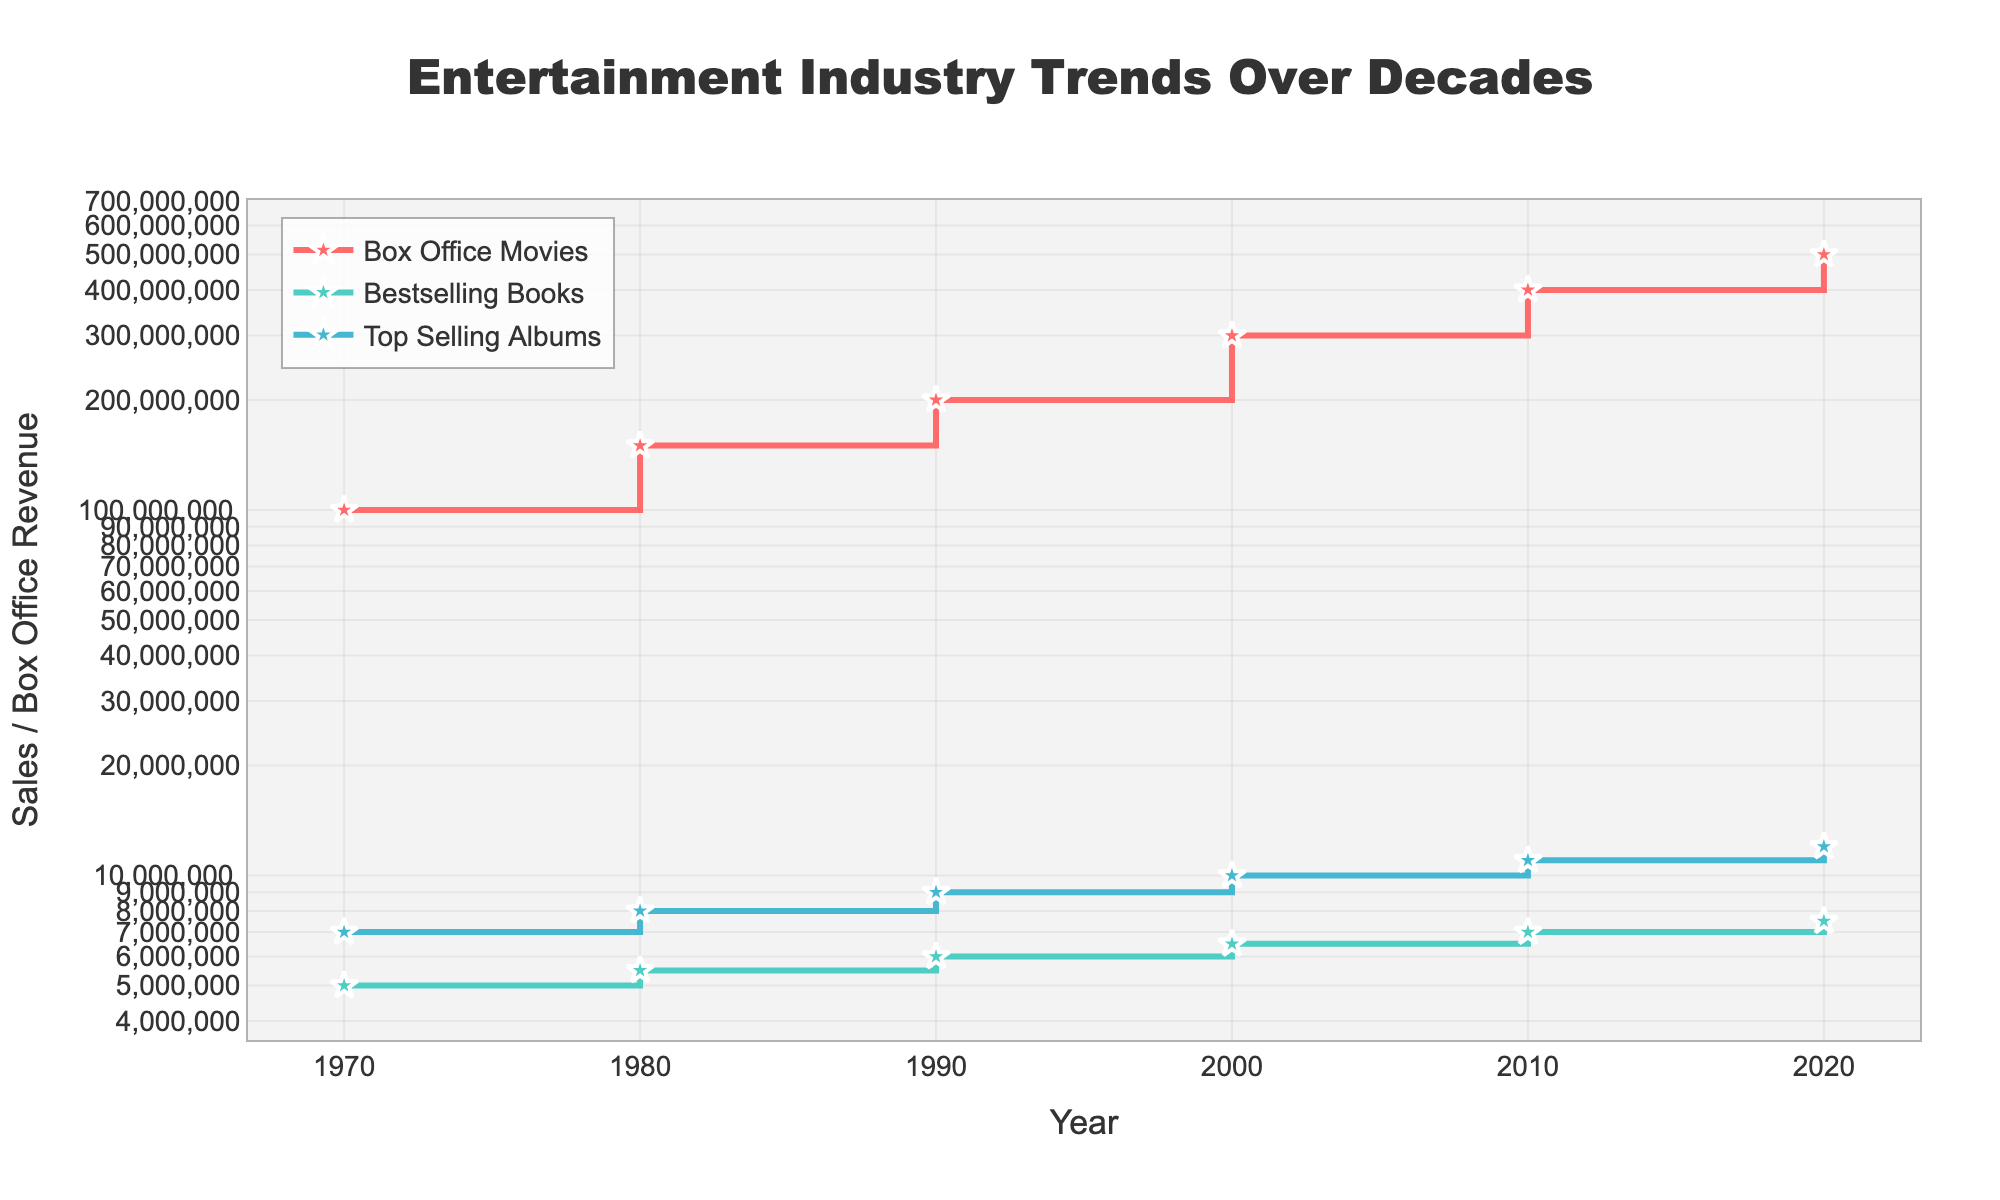How many decades are covered in the plot? There are labels on the x-axis representing each decade from 1970 to 2020. Count the number of these labels to get the total number of decades covered.
Answer: 6 Which category has the highest value in 2020? Look at the data points for the year 2020. Compare the values for Box_Office_Movies, Bestselling_Books, and Top_Selling_Albums. The highest value indicates the category with the maximum sales/revenue.
Answer: Box_Office_Movies What's the sales difference between Top Selling Albums and Bestselling Books in 2010? Find the sales values for both categories in 2010. Subtract the sales of Bestselling_Books from Top_Selling_Albums.
Answer: 4,000,000 Describe the overall trend for Box Office Movies over the decades. Look at the data points for Box_Office_Movies from 1970 to 2020. Notice if the values increase, decrease, or remain stable over the years.
Answer: Increasing Which decade saw the smallest increase in Box Office Movies revenue? Calculate the differences in Box_Office_Movies revenue between consecutive decades. Identify the smallest value among these differences.
Answer: 1970-1980 Are the sales/revenue values for all three categories plotted on a linear or logarithmic scale? By observing the axis labels and scale evenly spaced out but with orders of magnitude difference, it indicates the use of a logarithmic scale.
Answer: Logarithmic What's the ratio of sales between Top Selling Albums and Bestselling Books in 1990? Identify the sales values for the categories in 1990. Divide the value of Top_Selling_Albums by Bestselling_Books to get the ratio.
Answer: 1.5 Which category shows the most consistent increase in value over the decades? Consistent increase can be judged by minimal fluctuation and regular increments in the plotted data points. Compare the lines for each category to see which maintains a steady upward trend.
Answer: Bestselling_Books How many categories are depicted in the plot? By examining the legend and the different plotted lines, count the unique categories presented.
Answer: 3 In which decade did Bestselling Books have the smallest sales increase? Calculate the differences in sales for Bestselling_Books between consecutive decades, and find the smallest value among these differences.
Answer: 1970-1980 